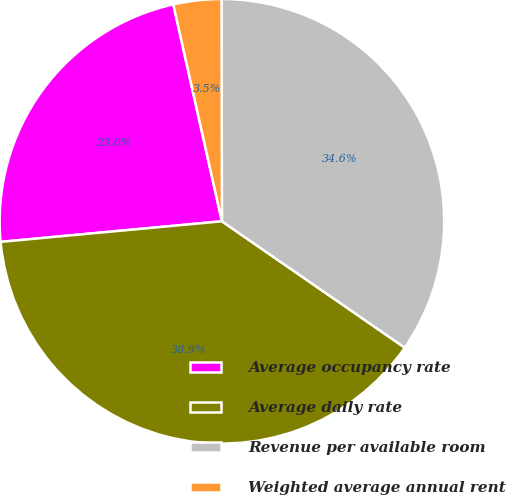Convert chart to OTSL. <chart><loc_0><loc_0><loc_500><loc_500><pie_chart><fcel>Average occupancy rate<fcel>Average daily rate<fcel>Revenue per available room<fcel>Weighted average annual rent<nl><fcel>22.97%<fcel>38.9%<fcel>34.65%<fcel>3.48%<nl></chart> 